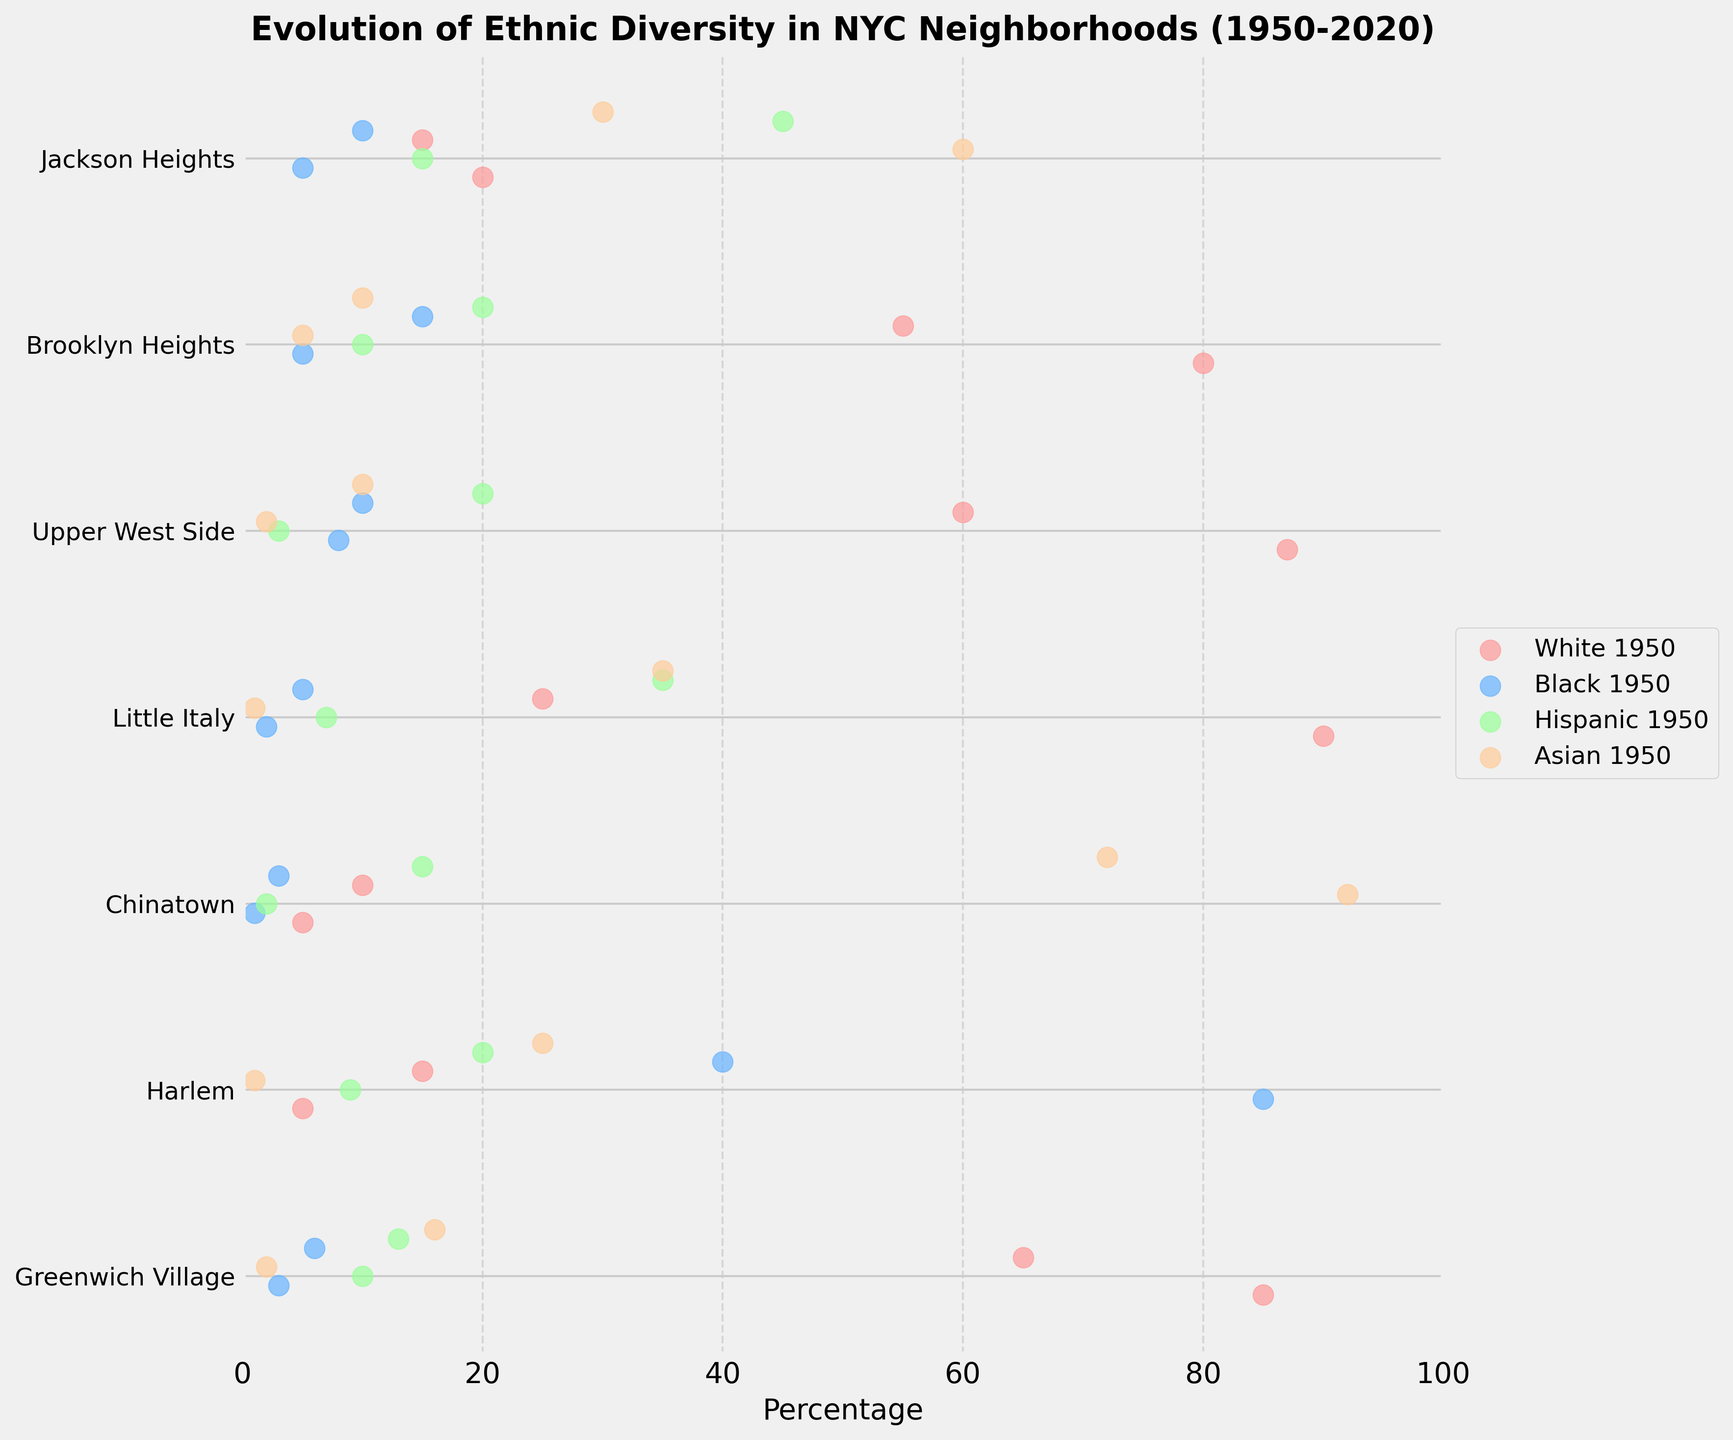What is the percentage of the Hispanic population in Little Italy in 1950? Look at the data point for the Hispanic population in Little Italy in 1950 found in the orange dots. The dot representing 1950 shows 7.
Answer: 7% What is the neighborhood with the highest increase in the Asian population from 1950 to 2020? Compare the differences in the Asian population percentages for each neighborhood from 1950 to 2020. Chinatown shows the largest increase from 92% in 1950 to 72% in 2020, yielding a significant decrease, but Jackson Heights shows an increase from 60% to 72%.
Answer: Jackson Heights In 2020, which neighborhood has the lowest percentage of White population? Compare the white population percentages across all neighborhoods in 2020 shown by the red dots. The lowest value is for Little Italy at 25%.
Answer: Little Italy Which neighborhood experienced the most diverse ethnic change from 1950 to 2020? Compare the diversity changes by noting the variations in ethnic percentages between 1950 and 2020 for each neighborhood. Little Italy shows significant changes across all ethnicities, indicating a major shift in diversity.
Answer: Little Italy What is the difference in the Black population percentage in Harlem between 1950 and 2020? Refer to the Blue dots representing Harlem for both years. Calculate the difference between 85% in 1950 and 40% in 2020.
Answer: 45% How did the Hispanic population in Jackson Heights change between 1950 and 2020? Refer to the Orange dots for Jackson Heights for the years 1950 and 2020. The population increases from 15% in 1950 to 45% in 2020.
Answer: Increased by 30% Which ethnic group in Greenwich Village experienced the largest percentage growth from 1950 to 2020? Compare the changes in population percentages for each ethnic group in Greenwich Village from 1950 to 2020. The Asian population grew from 2% to 16%, marking the largest growth.
Answer: Asian Is the Black population in Brooklyn Heights higher in 2020 compared to 1950? Look at the Black population percentages for Brooklyn Heights in both years. It increases from 5% in 1950 to 15% in 2020.
Answer: Yes Which neighborhood maintained the highest percentage of its original ethnic population from 1950 to 2020? Compare the changes in percentages for the dominant ethnic group of each neighborhood from 1950 to 2020. Chinatown remains predominantly Asian, with a decrease from 92% to 72%, still representing the highest maintenance of its original population.
Answer: Chinatown What is the percentage change of the White population in Upper West Side from 1950 to 2020? Subtract the 2020 percentage of the White population in Upper West Side (60%) from the 1950 percentage (87%) to find the percentage change.
Answer: Decreased by 27% 